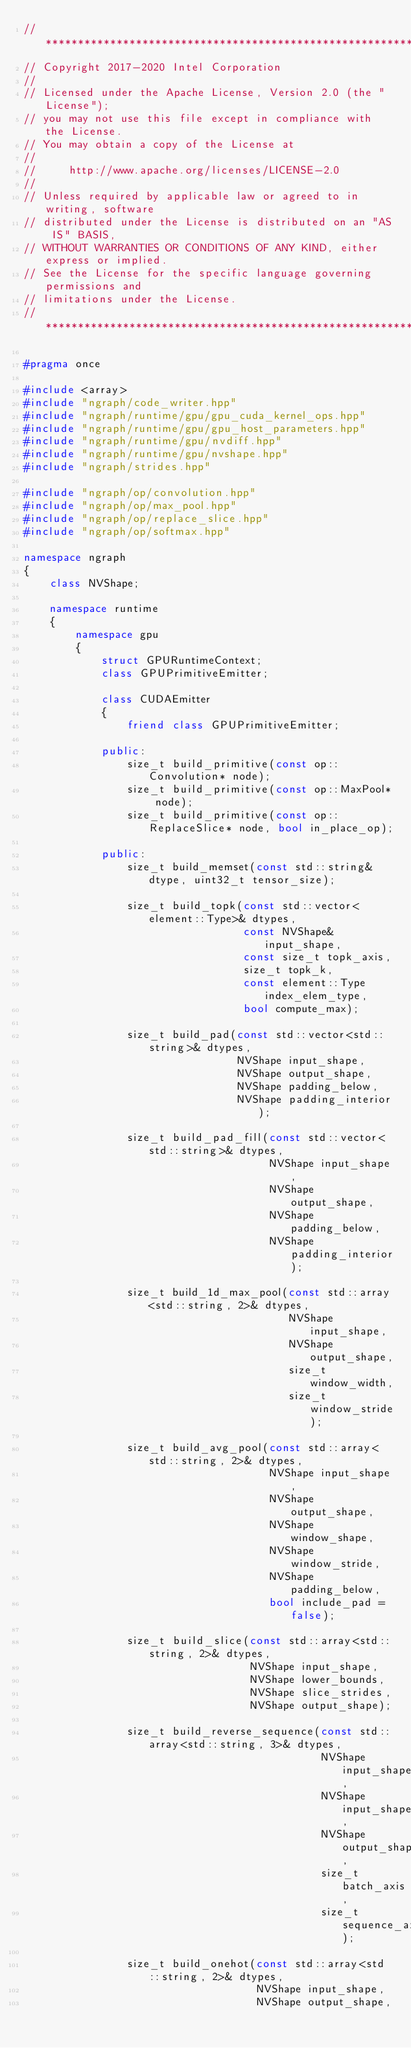Convert code to text. <code><loc_0><loc_0><loc_500><loc_500><_C++_>//*****************************************************************************
// Copyright 2017-2020 Intel Corporation
//
// Licensed under the Apache License, Version 2.0 (the "License");
// you may not use this file except in compliance with the License.
// You may obtain a copy of the License at
//
//     http://www.apache.org/licenses/LICENSE-2.0
//
// Unless required by applicable law or agreed to in writing, software
// distributed under the License is distributed on an "AS IS" BASIS,
// WITHOUT WARRANTIES OR CONDITIONS OF ANY KIND, either express or implied.
// See the License for the specific language governing permissions and
// limitations under the License.
//*****************************************************************************

#pragma once

#include <array>
#include "ngraph/code_writer.hpp"
#include "ngraph/runtime/gpu/gpu_cuda_kernel_ops.hpp"
#include "ngraph/runtime/gpu/gpu_host_parameters.hpp"
#include "ngraph/runtime/gpu/nvdiff.hpp"
#include "ngraph/runtime/gpu/nvshape.hpp"
#include "ngraph/strides.hpp"

#include "ngraph/op/convolution.hpp"
#include "ngraph/op/max_pool.hpp"
#include "ngraph/op/replace_slice.hpp"
#include "ngraph/op/softmax.hpp"

namespace ngraph
{
    class NVShape;

    namespace runtime
    {
        namespace gpu
        {
            struct GPURuntimeContext;
            class GPUPrimitiveEmitter;

            class CUDAEmitter
            {
                friend class GPUPrimitiveEmitter;

            public:
                size_t build_primitive(const op::Convolution* node);
                size_t build_primitive(const op::MaxPool* node);
                size_t build_primitive(const op::ReplaceSlice* node, bool in_place_op);

            public:
                size_t build_memset(const std::string& dtype, uint32_t tensor_size);

                size_t build_topk(const std::vector<element::Type>& dtypes,
                                  const NVShape& input_shape,
                                  const size_t topk_axis,
                                  size_t topk_k,
                                  const element::Type index_elem_type,
                                  bool compute_max);

                size_t build_pad(const std::vector<std::string>& dtypes,
                                 NVShape input_shape,
                                 NVShape output_shape,
                                 NVShape padding_below,
                                 NVShape padding_interior);

                size_t build_pad_fill(const std::vector<std::string>& dtypes,
                                      NVShape input_shape,
                                      NVShape output_shape,
                                      NVShape padding_below,
                                      NVShape padding_interior);

                size_t build_1d_max_pool(const std::array<std::string, 2>& dtypes,
                                         NVShape input_shape,
                                         NVShape output_shape,
                                         size_t window_width,
                                         size_t window_stride);

                size_t build_avg_pool(const std::array<std::string, 2>& dtypes,
                                      NVShape input_shape,
                                      NVShape output_shape,
                                      NVShape window_shape,
                                      NVShape window_stride,
                                      NVShape padding_below,
                                      bool include_pad = false);

                size_t build_slice(const std::array<std::string, 2>& dtypes,
                                   NVShape input_shape,
                                   NVShape lower_bounds,
                                   NVShape slice_strides,
                                   NVShape output_shape);

                size_t build_reverse_sequence(const std::array<std::string, 3>& dtypes,
                                              NVShape input_shape0,
                                              NVShape input_shape1,
                                              NVShape output_shape,
                                              size_t batch_axis,
                                              size_t sequence_axis);

                size_t build_onehot(const std::array<std::string, 2>& dtypes,
                                    NVShape input_shape,
                                    NVShape output_shape,</code> 